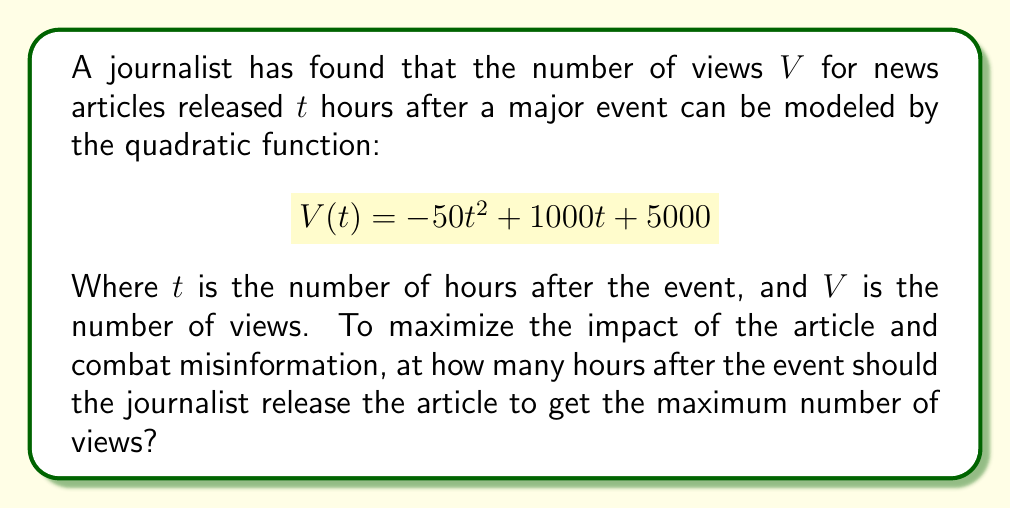Provide a solution to this math problem. To find the optimal time to release the news article, we need to determine the maximum point of the quadratic function. This can be done by following these steps:

1) The quadratic function is in the form $V(t) = at^2 + bt + c$, where:
   $a = -50$
   $b = 1000$
   $c = 5000$

2) For a quadratic function, the t-coordinate of the vertex (which gives the maximum or minimum point) is given by the formula:

   $$t = -\frac{b}{2a}$$

3) Substituting our values:

   $$t = -\frac{1000}{2(-50)} = -\frac{1000}{-100} = 10$$

4) Therefore, the function reaches its maximum value when $t = 10$ hours.

5) To verify this is a maximum (not a minimum), we can check that $a < 0$, which is true in this case ($a = -50$).

Thus, the journalist should release the article 10 hours after the major event to get the maximum number of views.
Answer: 10 hours 